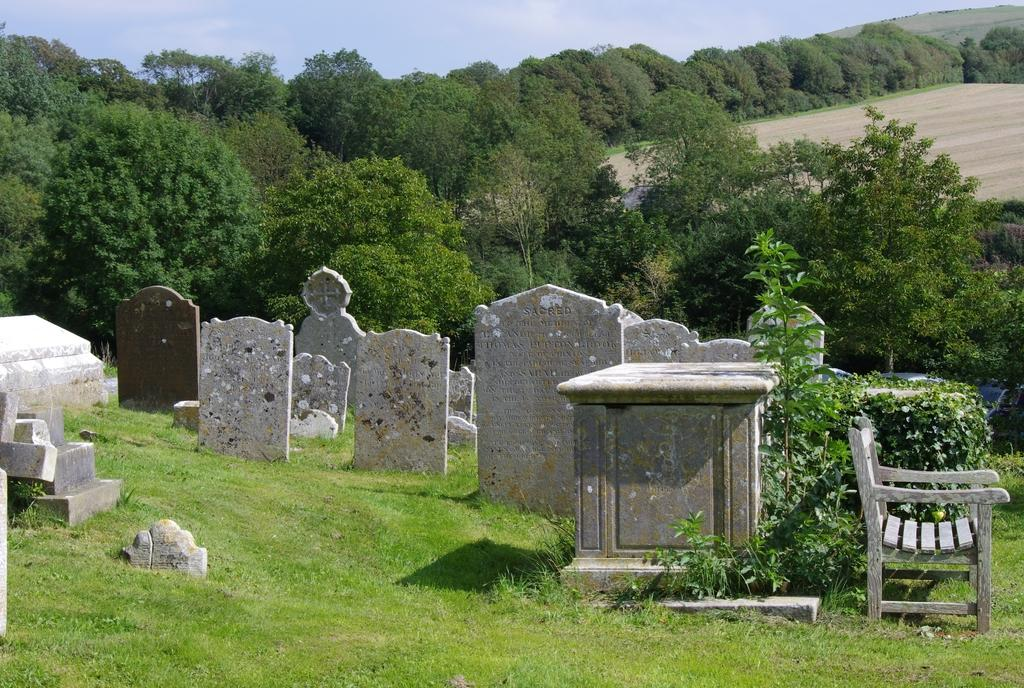What is located in the center of the image? There are plants, grass, a graveyard, and a chair in the center of the image. What type of vegetation is present in the center of the image? There is grass in the center of the image. What is the setting of the image? The image features a graveyard in the center. What is visible in the background of the image? The sky, clouds, and trees are visible in the background of the image. What type of can is visible in the image? There is no can present in the image. What sound can be heard coming from the thunder in the image? There is no thunder present in the image, so no sound can be heard. 